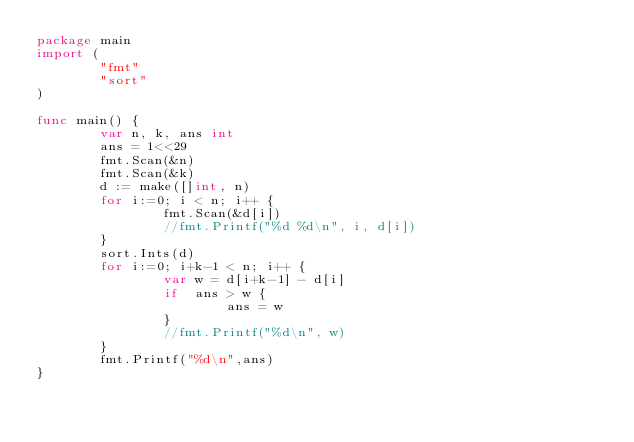<code> <loc_0><loc_0><loc_500><loc_500><_Go_>package main
import (
        "fmt"
        "sort"
)

func main() {
        var n, k, ans int
        ans = 1<<29
        fmt.Scan(&n)
        fmt.Scan(&k)
        d := make([]int, n)
        for i:=0; i < n; i++ {
                fmt.Scan(&d[i])
                //fmt.Printf("%d %d\n", i, d[i])
        }
        sort.Ints(d)
        for i:=0; i+k-1 < n; i++ {
                var w = d[i+k-1] - d[i]
                if  ans > w {
                        ans = w
                }
                //fmt.Printf("%d\n", w)
        }
        fmt.Printf("%d\n",ans)
}
</code> 